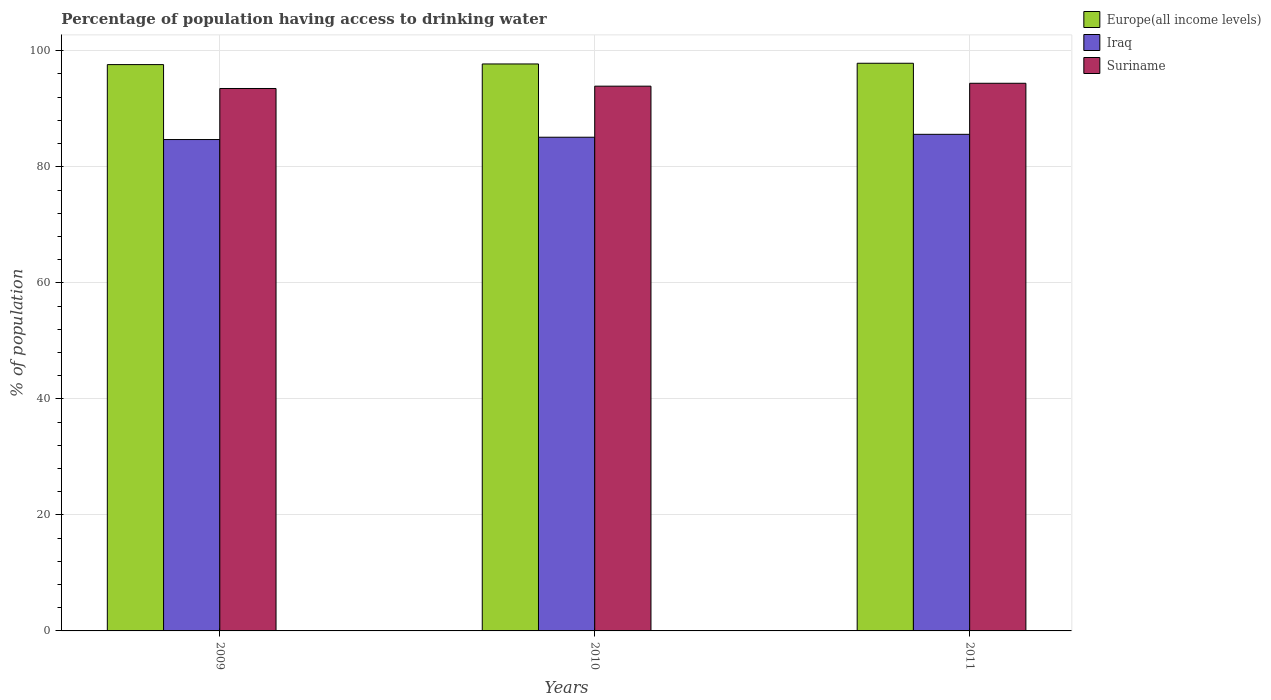How many different coloured bars are there?
Give a very brief answer. 3. Are the number of bars per tick equal to the number of legend labels?
Your answer should be compact. Yes. Are the number of bars on each tick of the X-axis equal?
Keep it short and to the point. Yes. How many bars are there on the 1st tick from the left?
Offer a terse response. 3. In how many cases, is the number of bars for a given year not equal to the number of legend labels?
Offer a terse response. 0. What is the percentage of population having access to drinking water in Iraq in 2011?
Your response must be concise. 85.6. Across all years, what is the maximum percentage of population having access to drinking water in Europe(all income levels)?
Provide a succinct answer. 97.85. Across all years, what is the minimum percentage of population having access to drinking water in Iraq?
Your response must be concise. 84.7. In which year was the percentage of population having access to drinking water in Suriname maximum?
Your answer should be very brief. 2011. In which year was the percentage of population having access to drinking water in Iraq minimum?
Keep it short and to the point. 2009. What is the total percentage of population having access to drinking water in Europe(all income levels) in the graph?
Offer a very short reply. 293.2. What is the difference between the percentage of population having access to drinking water in Iraq in 2010 and that in 2011?
Offer a very short reply. -0.5. What is the difference between the percentage of population having access to drinking water in Europe(all income levels) in 2011 and the percentage of population having access to drinking water in Iraq in 2010?
Offer a terse response. 12.75. What is the average percentage of population having access to drinking water in Iraq per year?
Provide a short and direct response. 85.13. In the year 2009, what is the difference between the percentage of population having access to drinking water in Europe(all income levels) and percentage of population having access to drinking water in Iraq?
Provide a short and direct response. 12.92. What is the ratio of the percentage of population having access to drinking water in Iraq in 2009 to that in 2010?
Offer a very short reply. 1. Is the difference between the percentage of population having access to drinking water in Europe(all income levels) in 2009 and 2010 greater than the difference between the percentage of population having access to drinking water in Iraq in 2009 and 2010?
Your answer should be very brief. Yes. What is the difference between the highest and the second highest percentage of population having access to drinking water in Suriname?
Offer a terse response. 0.5. What is the difference between the highest and the lowest percentage of population having access to drinking water in Europe(all income levels)?
Offer a very short reply. 0.23. In how many years, is the percentage of population having access to drinking water in Suriname greater than the average percentage of population having access to drinking water in Suriname taken over all years?
Make the answer very short. 1. Is the sum of the percentage of population having access to drinking water in Suriname in 2010 and 2011 greater than the maximum percentage of population having access to drinking water in Iraq across all years?
Your response must be concise. Yes. What does the 3rd bar from the left in 2011 represents?
Provide a succinct answer. Suriname. What does the 1st bar from the right in 2010 represents?
Make the answer very short. Suriname. Is it the case that in every year, the sum of the percentage of population having access to drinking water in Suriname and percentage of population having access to drinking water in Iraq is greater than the percentage of population having access to drinking water in Europe(all income levels)?
Your response must be concise. Yes. How many years are there in the graph?
Provide a short and direct response. 3. How many legend labels are there?
Offer a very short reply. 3. What is the title of the graph?
Your answer should be very brief. Percentage of population having access to drinking water. What is the label or title of the X-axis?
Provide a short and direct response. Years. What is the label or title of the Y-axis?
Your response must be concise. % of population. What is the % of population in Europe(all income levels) in 2009?
Ensure brevity in your answer.  97.62. What is the % of population of Iraq in 2009?
Provide a succinct answer. 84.7. What is the % of population of Suriname in 2009?
Ensure brevity in your answer.  93.5. What is the % of population in Europe(all income levels) in 2010?
Your answer should be very brief. 97.73. What is the % of population in Iraq in 2010?
Make the answer very short. 85.1. What is the % of population in Suriname in 2010?
Give a very brief answer. 93.9. What is the % of population of Europe(all income levels) in 2011?
Offer a very short reply. 97.85. What is the % of population of Iraq in 2011?
Your response must be concise. 85.6. What is the % of population of Suriname in 2011?
Your response must be concise. 94.4. Across all years, what is the maximum % of population in Europe(all income levels)?
Offer a terse response. 97.85. Across all years, what is the maximum % of population of Iraq?
Provide a short and direct response. 85.6. Across all years, what is the maximum % of population in Suriname?
Offer a terse response. 94.4. Across all years, what is the minimum % of population of Europe(all income levels)?
Keep it short and to the point. 97.62. Across all years, what is the minimum % of population in Iraq?
Provide a succinct answer. 84.7. Across all years, what is the minimum % of population of Suriname?
Keep it short and to the point. 93.5. What is the total % of population of Europe(all income levels) in the graph?
Your response must be concise. 293.2. What is the total % of population in Iraq in the graph?
Keep it short and to the point. 255.4. What is the total % of population in Suriname in the graph?
Provide a succinct answer. 281.8. What is the difference between the % of population of Europe(all income levels) in 2009 and that in 2010?
Offer a terse response. -0.11. What is the difference between the % of population in Europe(all income levels) in 2009 and that in 2011?
Give a very brief answer. -0.23. What is the difference between the % of population of Suriname in 2009 and that in 2011?
Ensure brevity in your answer.  -0.9. What is the difference between the % of population in Europe(all income levels) in 2010 and that in 2011?
Provide a succinct answer. -0.12. What is the difference between the % of population in Iraq in 2010 and that in 2011?
Your response must be concise. -0.5. What is the difference between the % of population of Europe(all income levels) in 2009 and the % of population of Iraq in 2010?
Offer a terse response. 12.52. What is the difference between the % of population in Europe(all income levels) in 2009 and the % of population in Suriname in 2010?
Your answer should be very brief. 3.72. What is the difference between the % of population in Europe(all income levels) in 2009 and the % of population in Iraq in 2011?
Your answer should be very brief. 12.02. What is the difference between the % of population of Europe(all income levels) in 2009 and the % of population of Suriname in 2011?
Provide a succinct answer. 3.22. What is the difference between the % of population in Iraq in 2009 and the % of population in Suriname in 2011?
Make the answer very short. -9.7. What is the difference between the % of population of Europe(all income levels) in 2010 and the % of population of Iraq in 2011?
Provide a short and direct response. 12.13. What is the difference between the % of population in Europe(all income levels) in 2010 and the % of population in Suriname in 2011?
Provide a succinct answer. 3.33. What is the difference between the % of population of Iraq in 2010 and the % of population of Suriname in 2011?
Make the answer very short. -9.3. What is the average % of population in Europe(all income levels) per year?
Offer a very short reply. 97.73. What is the average % of population in Iraq per year?
Ensure brevity in your answer.  85.13. What is the average % of population in Suriname per year?
Offer a terse response. 93.93. In the year 2009, what is the difference between the % of population in Europe(all income levels) and % of population in Iraq?
Offer a terse response. 12.92. In the year 2009, what is the difference between the % of population of Europe(all income levels) and % of population of Suriname?
Provide a short and direct response. 4.12. In the year 2009, what is the difference between the % of population of Iraq and % of population of Suriname?
Provide a short and direct response. -8.8. In the year 2010, what is the difference between the % of population of Europe(all income levels) and % of population of Iraq?
Ensure brevity in your answer.  12.63. In the year 2010, what is the difference between the % of population of Europe(all income levels) and % of population of Suriname?
Offer a very short reply. 3.83. In the year 2011, what is the difference between the % of population in Europe(all income levels) and % of population in Iraq?
Make the answer very short. 12.25. In the year 2011, what is the difference between the % of population in Europe(all income levels) and % of population in Suriname?
Provide a succinct answer. 3.45. What is the ratio of the % of population in Europe(all income levels) in 2009 to that in 2010?
Provide a short and direct response. 1. What is the ratio of the % of population in Iraq in 2009 to that in 2010?
Your answer should be compact. 1. What is the ratio of the % of population in Iraq in 2009 to that in 2011?
Provide a short and direct response. 0.99. What is the ratio of the % of population in Europe(all income levels) in 2010 to that in 2011?
Offer a terse response. 1. What is the difference between the highest and the second highest % of population in Europe(all income levels)?
Provide a succinct answer. 0.12. What is the difference between the highest and the second highest % of population of Iraq?
Offer a terse response. 0.5. What is the difference between the highest and the lowest % of population in Europe(all income levels)?
Give a very brief answer. 0.23. What is the difference between the highest and the lowest % of population of Iraq?
Offer a terse response. 0.9. What is the difference between the highest and the lowest % of population in Suriname?
Provide a short and direct response. 0.9. 